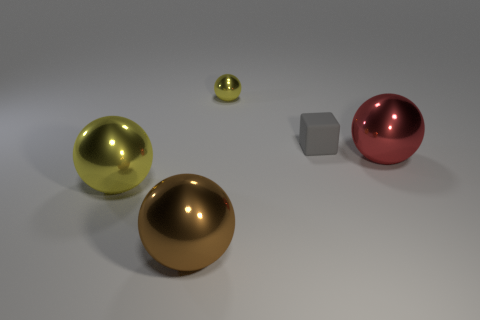Subtract all large brown metal spheres. How many spheres are left? 3 Subtract all green blocks. How many yellow balls are left? 2 Add 4 tiny cubes. How many objects exist? 9 Subtract all red balls. How many balls are left? 3 Subtract all cubes. How many objects are left? 4 Subtract 2 spheres. How many spheres are left? 2 Subtract all yellow cubes. Subtract all red balls. How many cubes are left? 1 Subtract all large blue rubber cubes. Subtract all metallic objects. How many objects are left? 1 Add 3 big yellow metal balls. How many big yellow metal balls are left? 4 Add 4 large red metallic things. How many large red metallic things exist? 5 